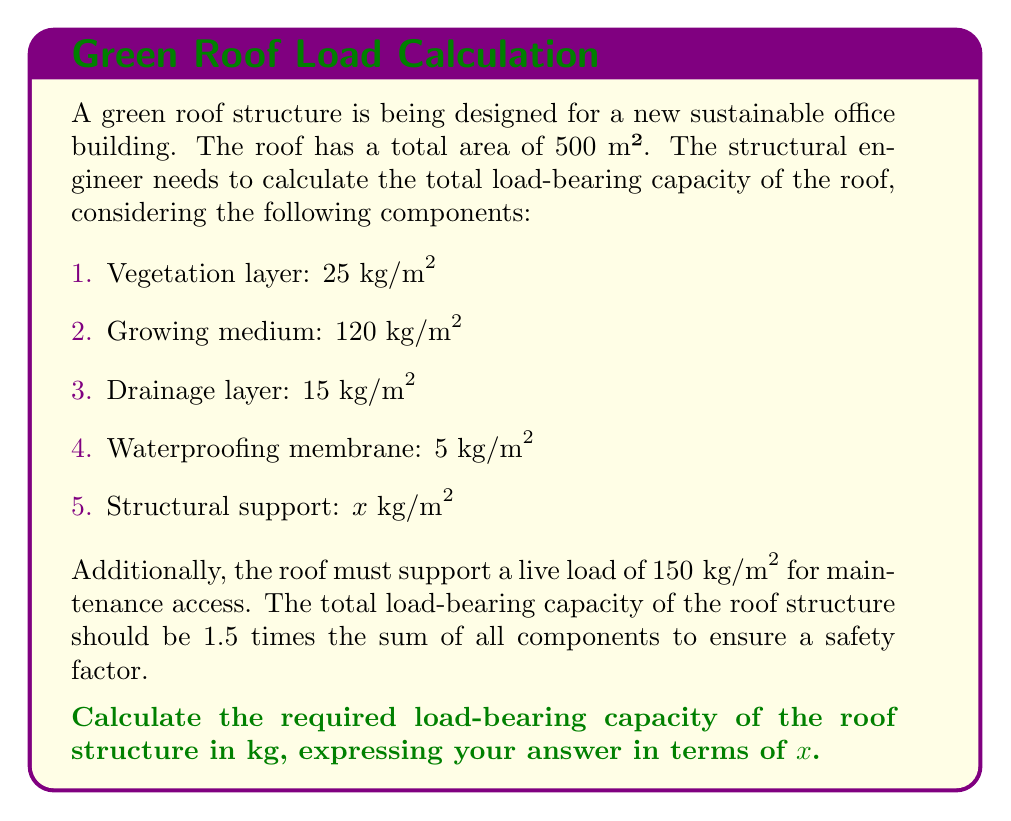Show me your answer to this math problem. Let's approach this problem step by step:

1. First, let's sum up the known components of the green roof system:
   
   $25 + 120 + 15 + 5 = 165 \text{ kg/m}^2$

2. Add the live load for maintenance access:
   
   $165 + 150 = 315 \text{ kg/m}^2$

3. Now, we have the total load per square meter, including the unknown structural support $x$:
   
   $315 + x \text{ kg/m}^2$

4. The total load-bearing capacity should be 1.5 times this sum:
   
   $1.5(315 + x) \text{ kg/m}^2$

5. To get the total load for the entire roof, we multiply by the area:
   
   $1.5(315 + x) \cdot 500 \text{ m}^2$

6. Simplify the expression:
   
   $750(315 + x) \text{ kg}$
   
   $236,250 + 750x \text{ kg}$

Thus, the required load-bearing capacity of the roof structure is $236,250 + 750x \text{ kg}$.
Answer: $236,250 + 750x \text{ kg}$ 